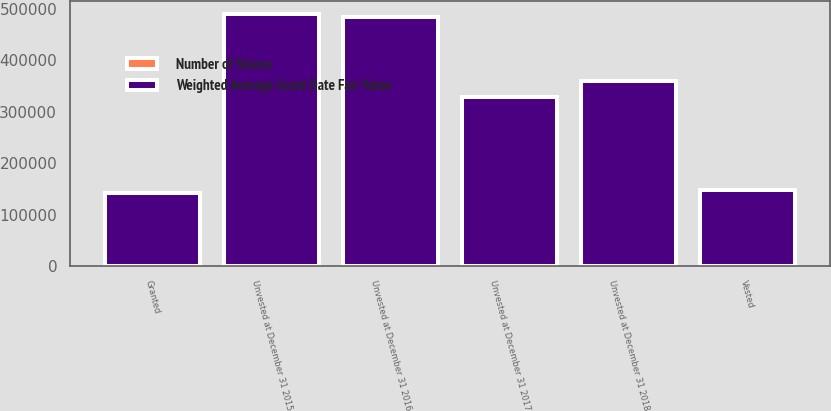Convert chart. <chart><loc_0><loc_0><loc_500><loc_500><stacked_bar_chart><ecel><fcel>Unvested at December 31 2015<fcel>Granted<fcel>Vested<fcel>Unvested at December 31 2016<fcel>Unvested at December 31 2017<fcel>Unvested at December 31 2018<nl><fcel>Weighted Average Grant Date Fair Value<fcel>490673<fcel>142114<fcel>148733<fcel>484054<fcel>328187<fcel>360512<nl><fcel>Number of Shares<fcel>67.04<fcel>74.71<fcel>62.84<fcel>70.58<fcel>71.68<fcel>93.74<nl></chart> 